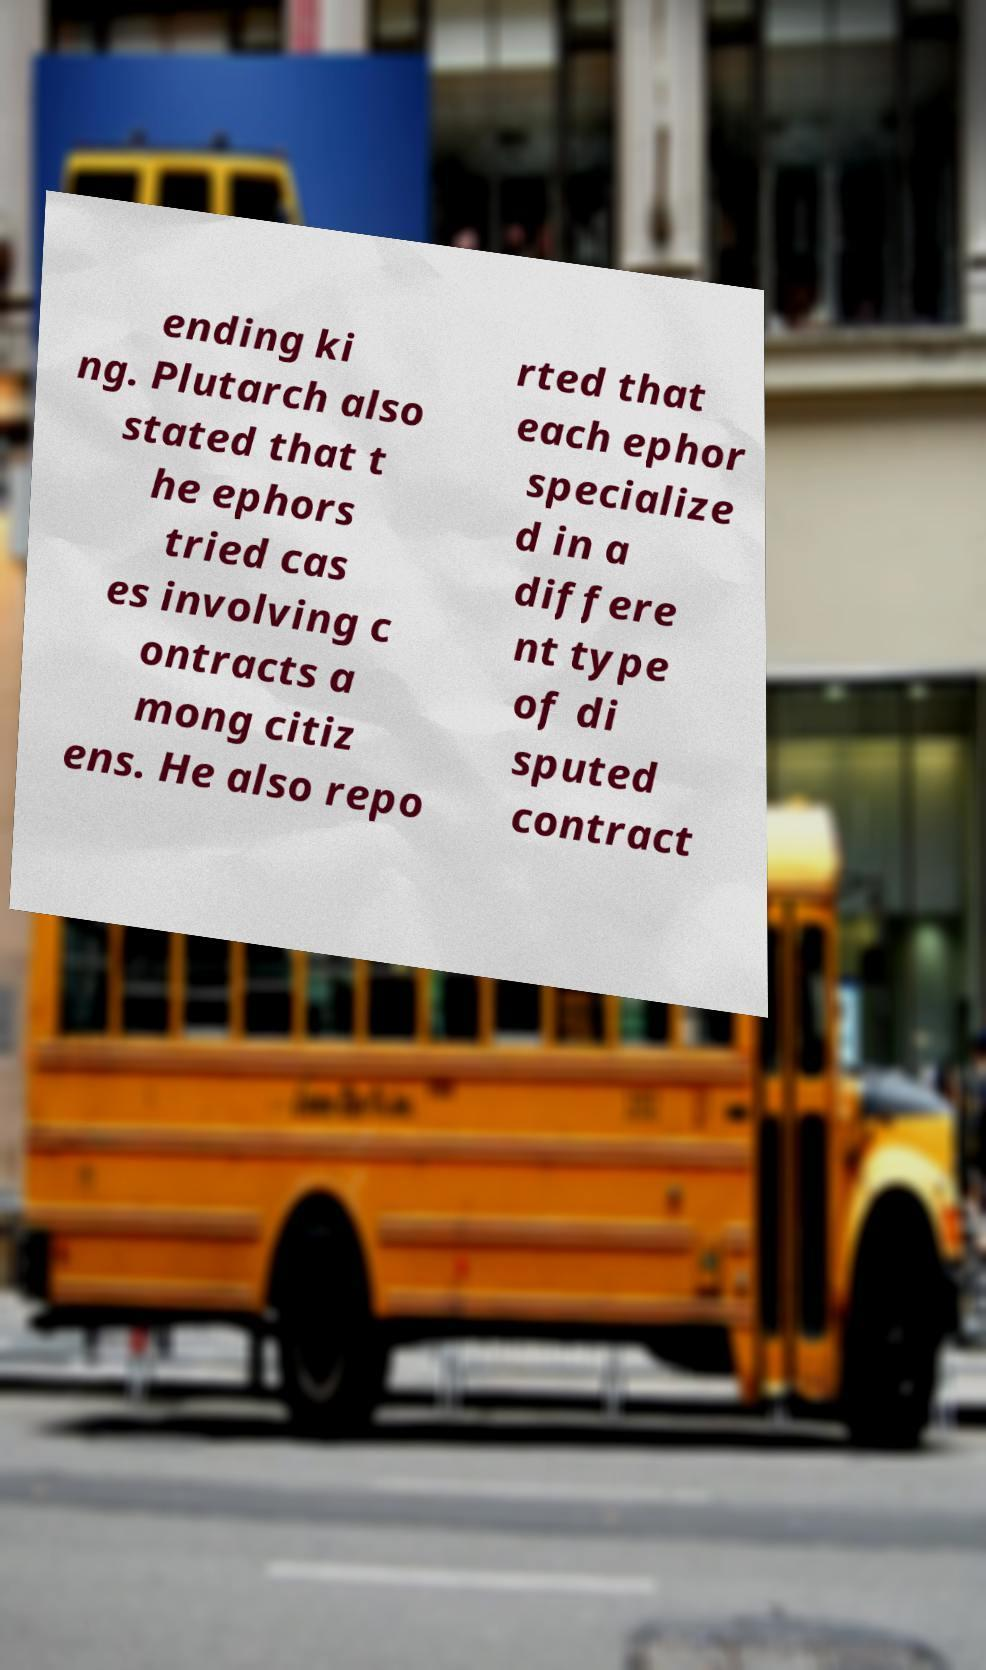For documentation purposes, I need the text within this image transcribed. Could you provide that? ending ki ng. Plutarch also stated that t he ephors tried cas es involving c ontracts a mong citiz ens. He also repo rted that each ephor specialize d in a differe nt type of di sputed contract 